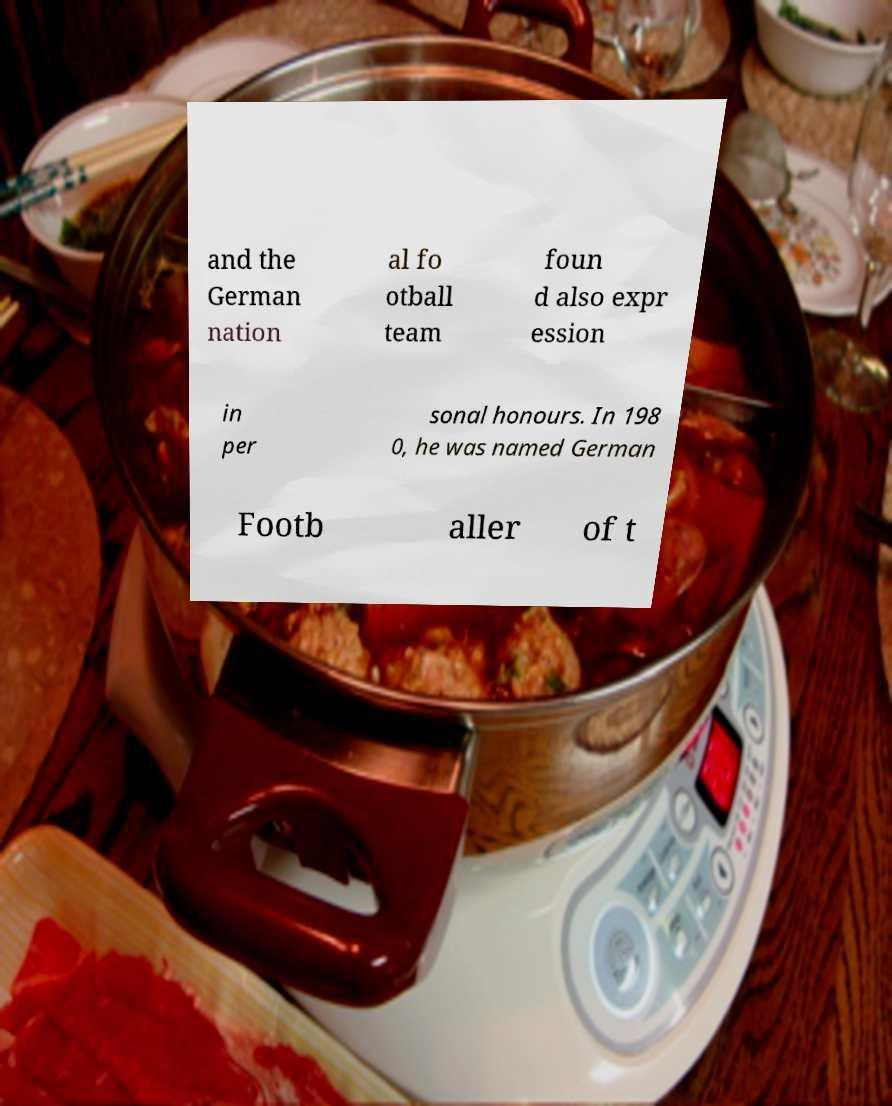What messages or text are displayed in this image? I need them in a readable, typed format. and the German nation al fo otball team foun d also expr ession in per sonal honours. In 198 0, he was named German Footb aller of t 